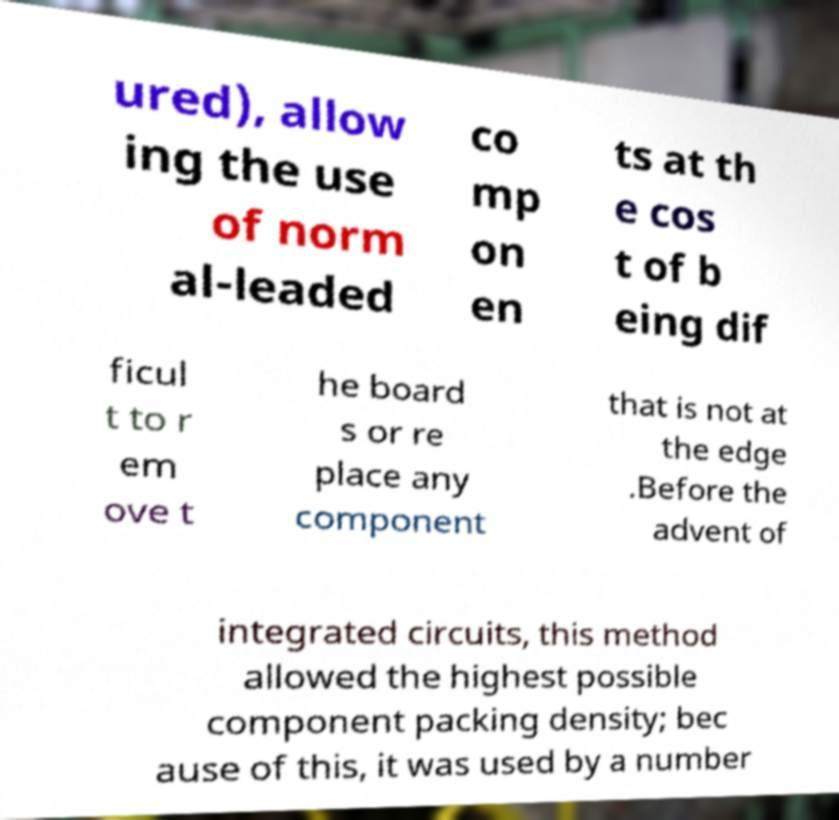I need the written content from this picture converted into text. Can you do that? ured), allow ing the use of norm al-leaded co mp on en ts at th e cos t of b eing dif ficul t to r em ove t he board s or re place any component that is not at the edge .Before the advent of integrated circuits, this method allowed the highest possible component packing density; bec ause of this, it was used by a number 